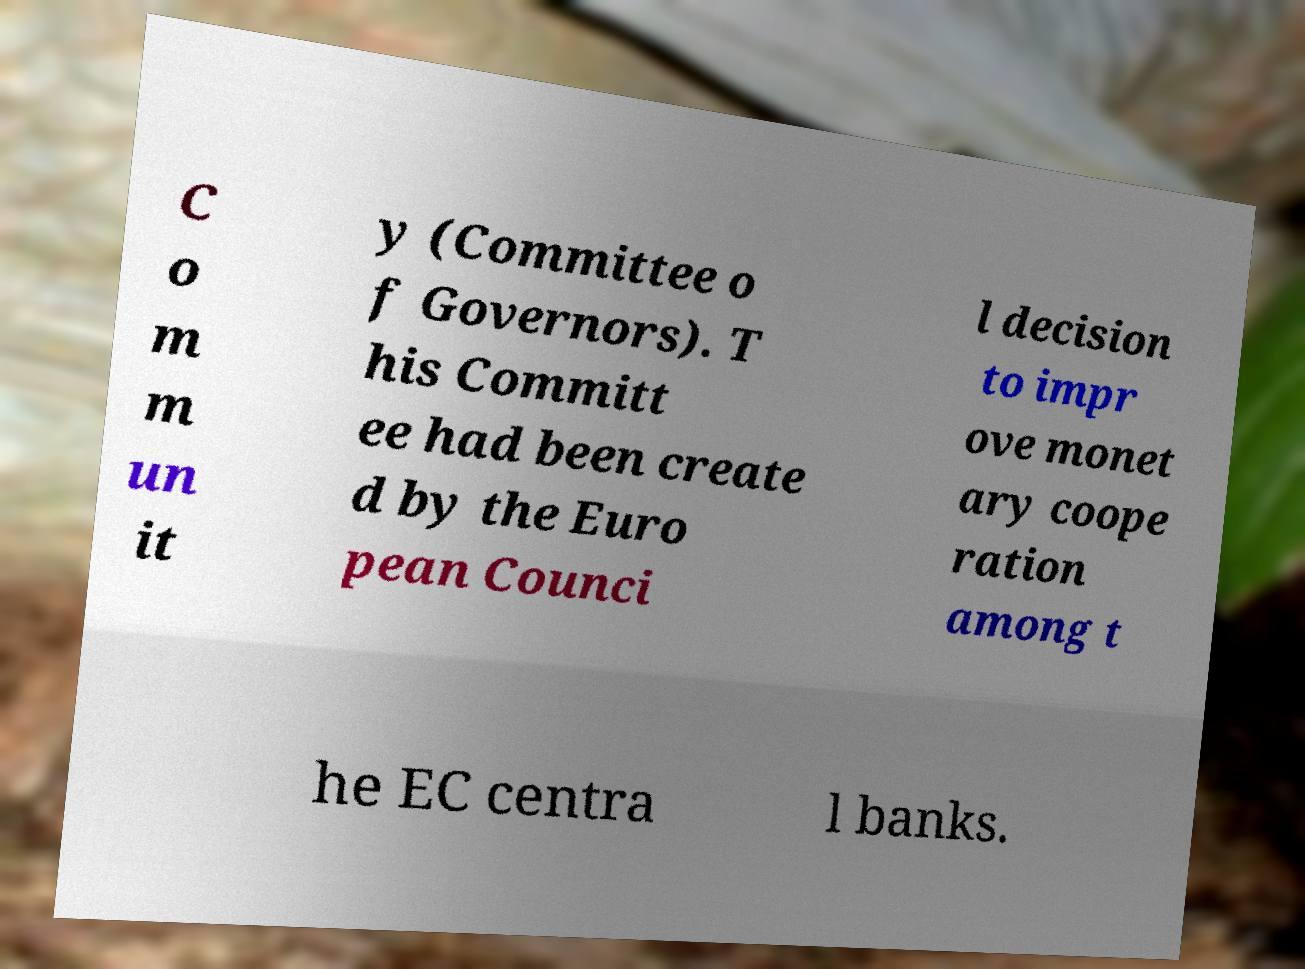I need the written content from this picture converted into text. Can you do that? C o m m un it y (Committee o f Governors). T his Committ ee had been create d by the Euro pean Counci l decision to impr ove monet ary coope ration among t he EC centra l banks. 